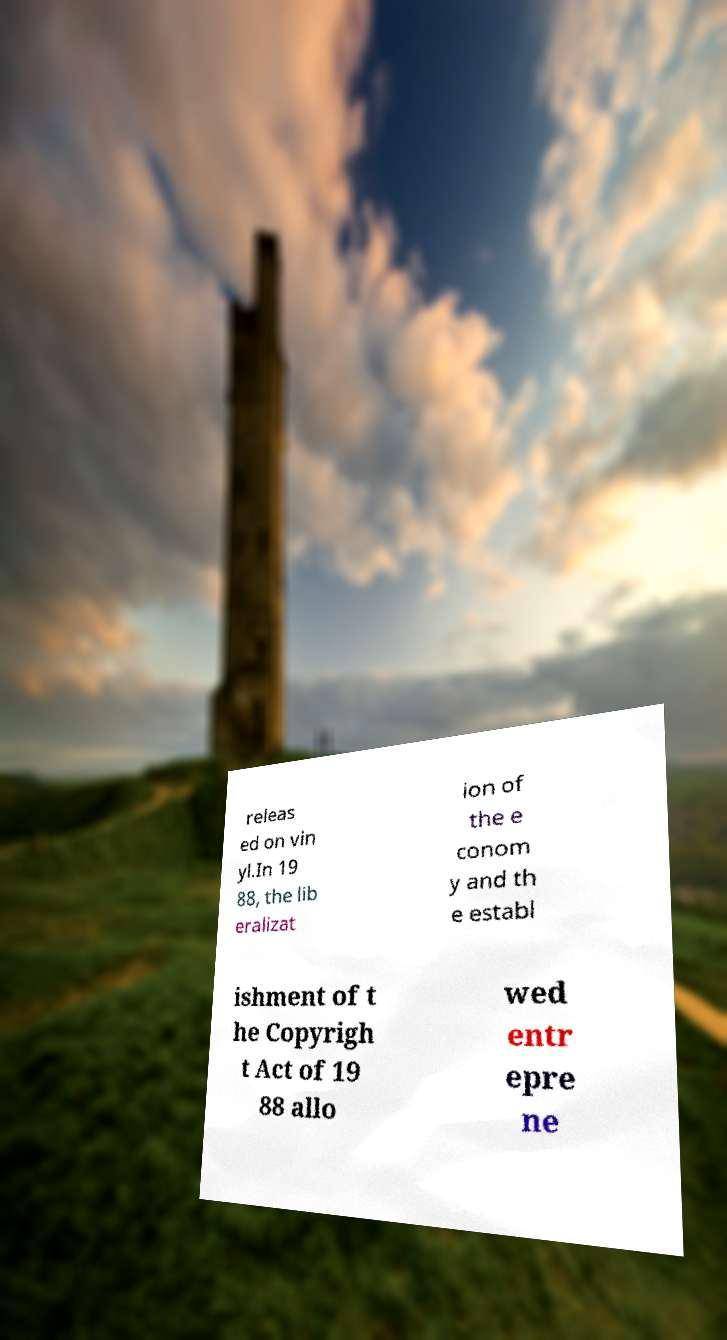I need the written content from this picture converted into text. Can you do that? releas ed on vin yl.In 19 88, the lib eralizat ion of the e conom y and th e establ ishment of t he Copyrigh t Act of 19 88 allo wed entr epre ne 